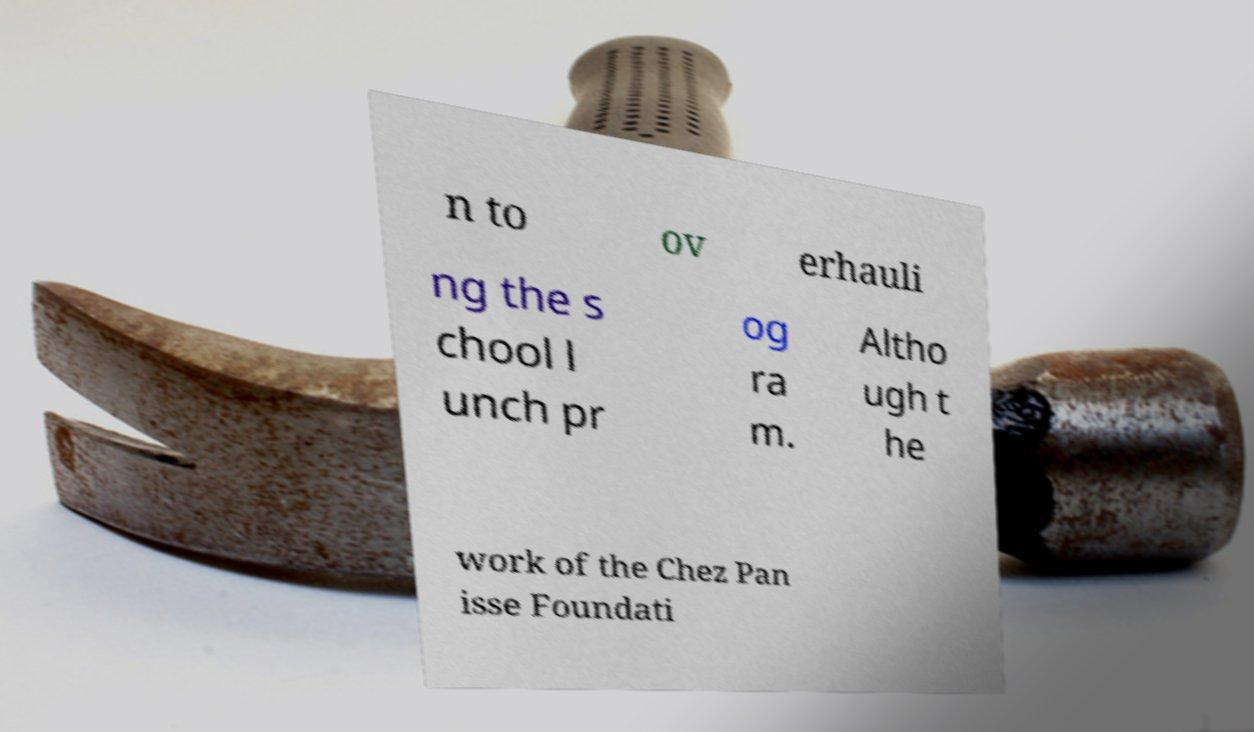Please identify and transcribe the text found in this image. n to ov erhauli ng the s chool l unch pr og ra m. Altho ugh t he work of the Chez Pan isse Foundati 